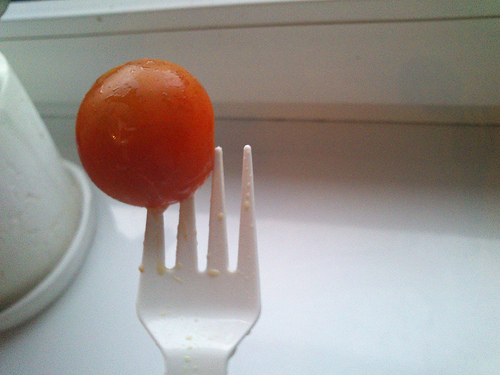<image>
Is the tomato on the table? No. The tomato is not positioned on the table. They may be near each other, but the tomato is not supported by or resting on top of the table. Is there a cherry next to the fork? No. The cherry is not positioned next to the fork. They are located in different areas of the scene. Where is the tomato in relation to the fork? Is it in front of the fork? Yes. The tomato is positioned in front of the fork, appearing closer to the camera viewpoint. 